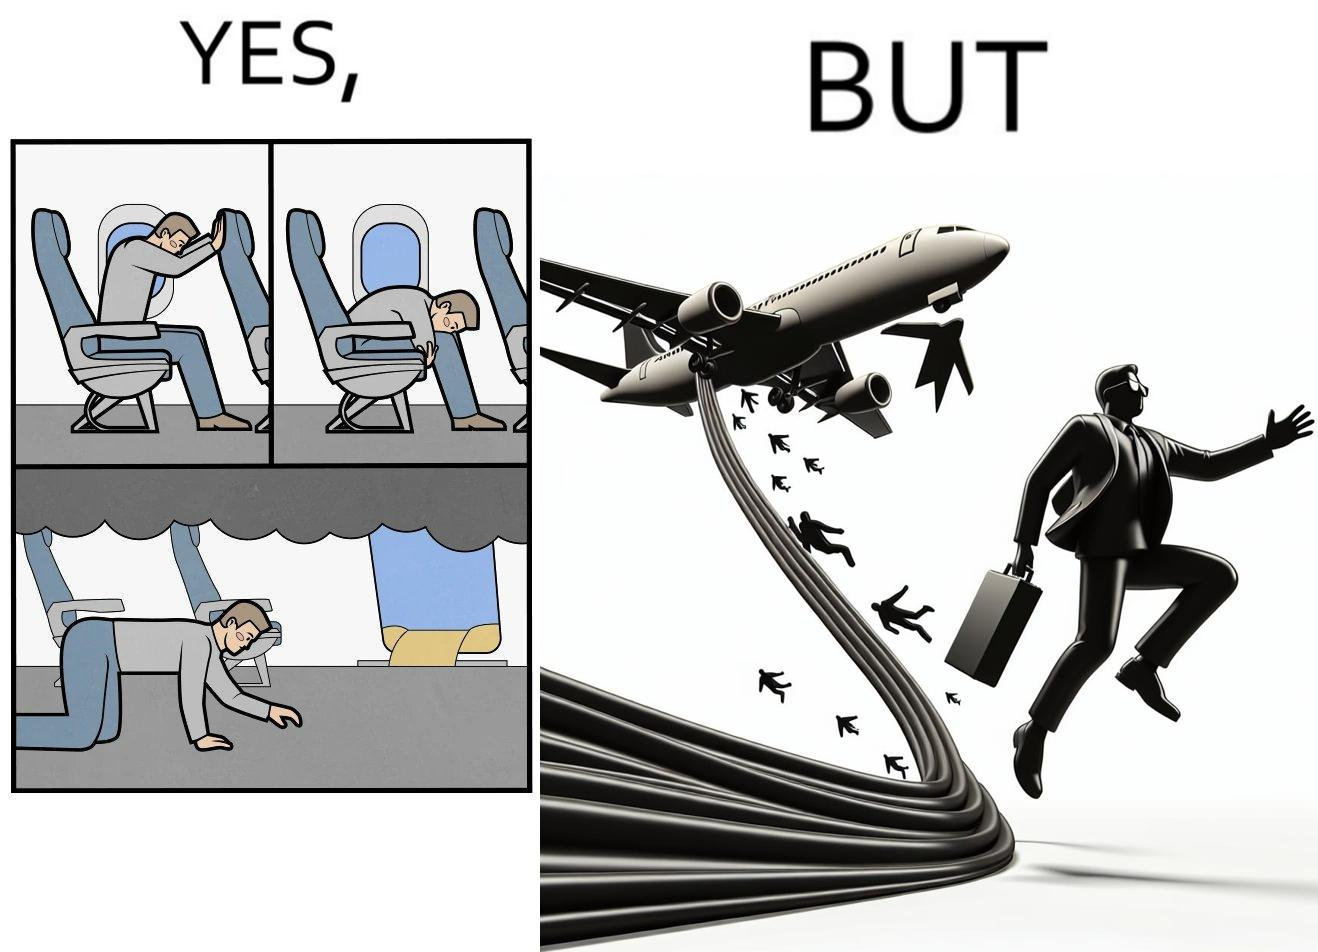What do you see in each half of this image? In the left part of the image: They are images of what one should do in an airplane in case of an imminent collision and fire In the right part of the image: It shows a man jumping out of an airplane in case of an emergency and using the emergency inflatable slides 